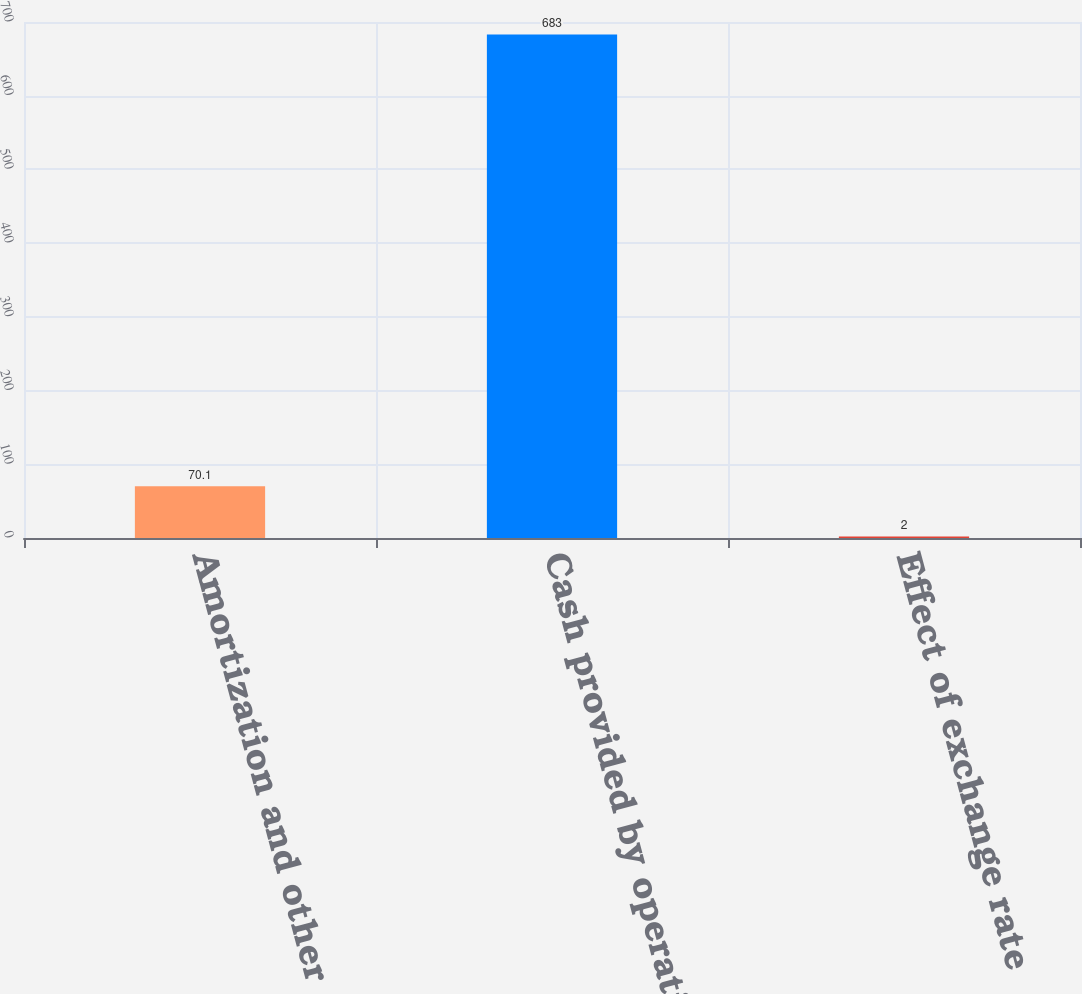Convert chart to OTSL. <chart><loc_0><loc_0><loc_500><loc_500><bar_chart><fcel>Amortization and other<fcel>Cash provided by operations<fcel>Effect of exchange rate<nl><fcel>70.1<fcel>683<fcel>2<nl></chart> 